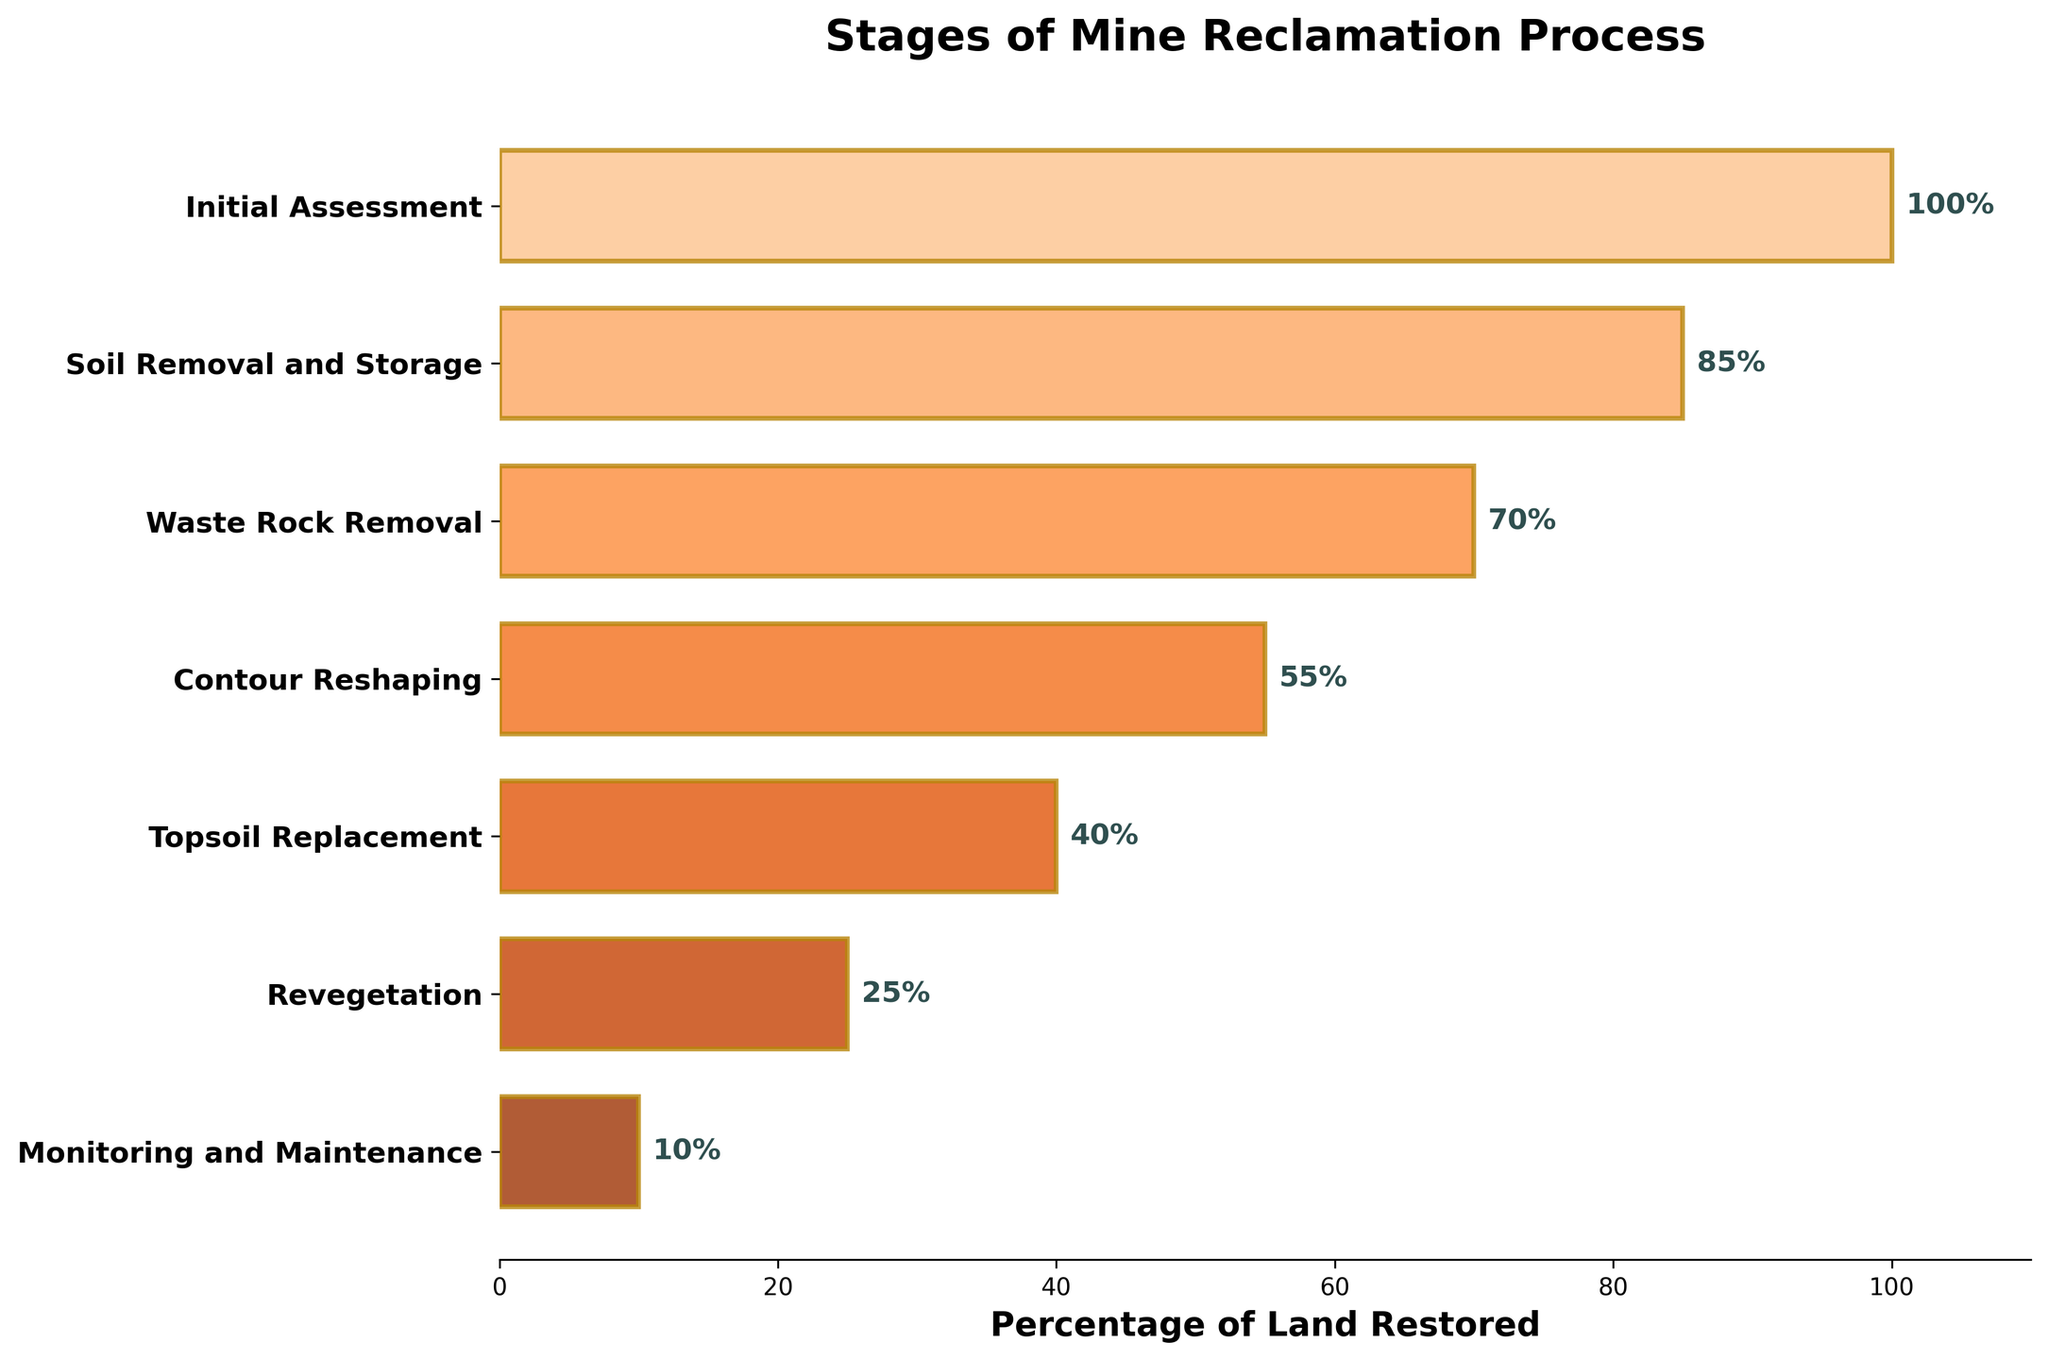what does the title of the figure say? The title is typically located at the top of the figure and in this case, it reads: "Stages of Mine Reclamation Process".
Answer: Stages of Mine Reclamation Process Which stage has the highest percentage of land restored? The percentage of land restored is displayed on the horizontal bars for each stage. The stage with the highest percentage is "Initial Assessment" with 100%.
Answer: Initial Assessment Which stage shows that only 25% of the land is restored? Looking at the percentage labels on the horizontal bars, "Revegetation" shows 25% of the land restored.
Answer: Revegetation What's the difference in percentage of land restored between the "Contour Reshaping" and "Topsoil Replacement" stages? The "Contour Reshaping" stage shows 55%, and the "Topsoil Replacement" stage shows 40%. The difference is 55% - 40% = 15%.
Answer: 15% Which stage has a larger percentage of land restored: "Waste Rock Removal" or "Monitoring and Maintenance"? By comparing the horizontal bars, "Waste Rock Removal" has 70% and "Monitoring and Maintenance" has 10%. Thus, "Waste Rock Removal" has a larger percentage.
Answer: Waste Rock Removal How many stages are involved in the mine reclamation process according to the figure? Count the number of horizontal bars or the number of stages listed on the y-axis. There are 7 stages.
Answer: 7 What is the combined percentage of land restored in the "Soil Removal and Storage" and "Revegetation" stages? "Soil Removal and Storage" shows 85%, and "Revegetation" shows 25%. The combined percentage is 85% + 25% = 110%.
Answer: 110% What is the average percentage of land restored across all stages? Sum the percentages from all stages (100 + 85 + 70 + 55 + 40 + 25 + 10 = 385) and divide by the number of stages (7). The average is 385 / 7 ≈ 55%.
Answer: 55% Which stages have restored more than 50% of the land? Observing the percentages on the horizontal bars, stages with more than 50% are "Initial Assessment" (100%), "Soil Removal and Storage" (85%), "Waste Rock Removal" (70%), and "Contour Reshaping" (55%).
Answer: Initial Assessment, Soil Removal and Storage, Waste Rock Removal, Contour Reshaping What percentage of the land is restored at the final stage of "Monitoring and Maintenance"? The final horizontal bar labeled "Monitoring and Maintenance" shows a percentage of 10%.
Answer: 10% 